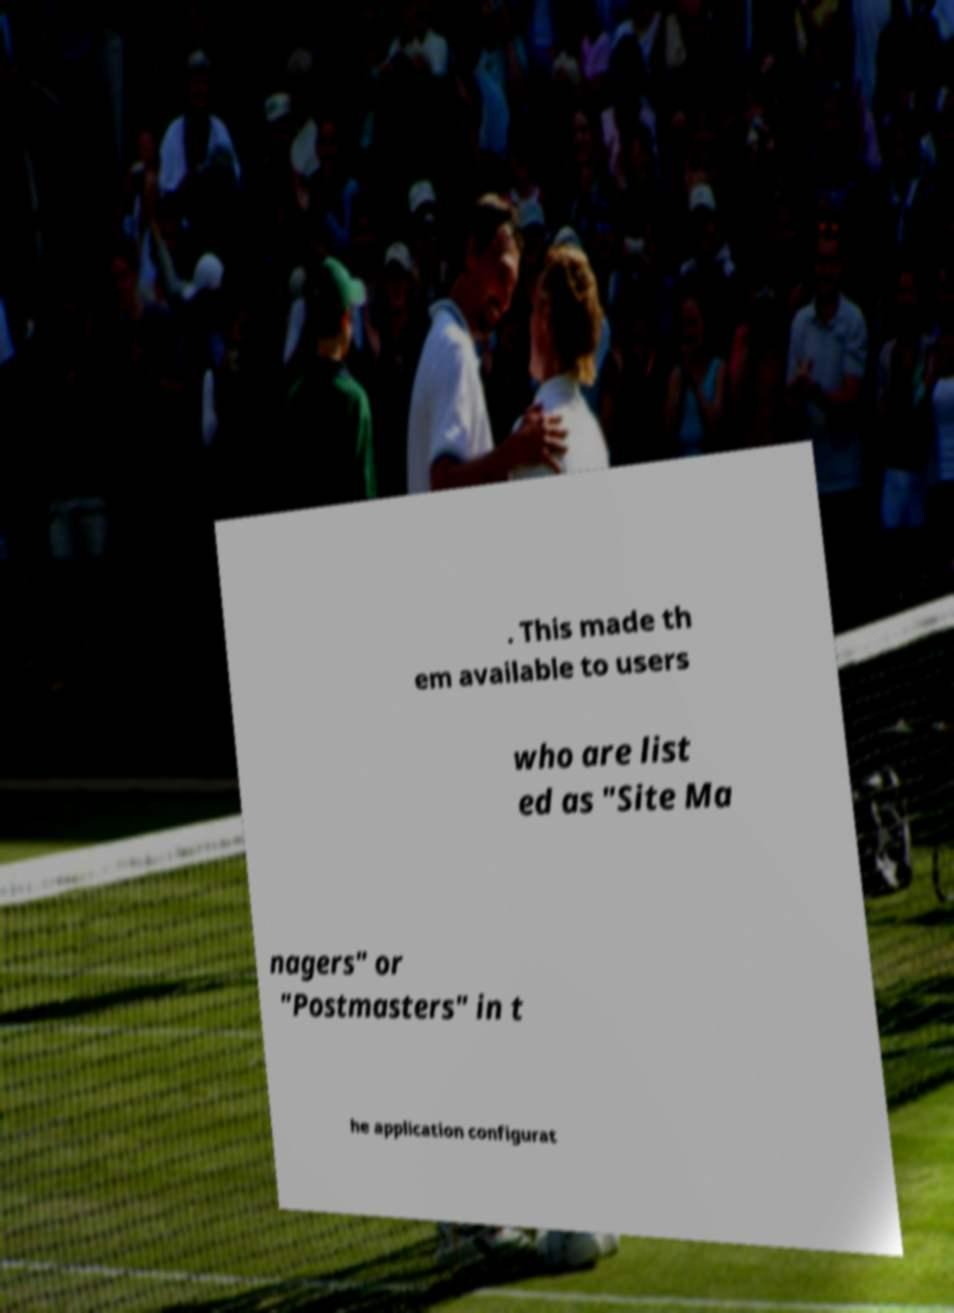I need the written content from this picture converted into text. Can you do that? . This made th em available to users who are list ed as "Site Ma nagers" or "Postmasters" in t he application configurat 